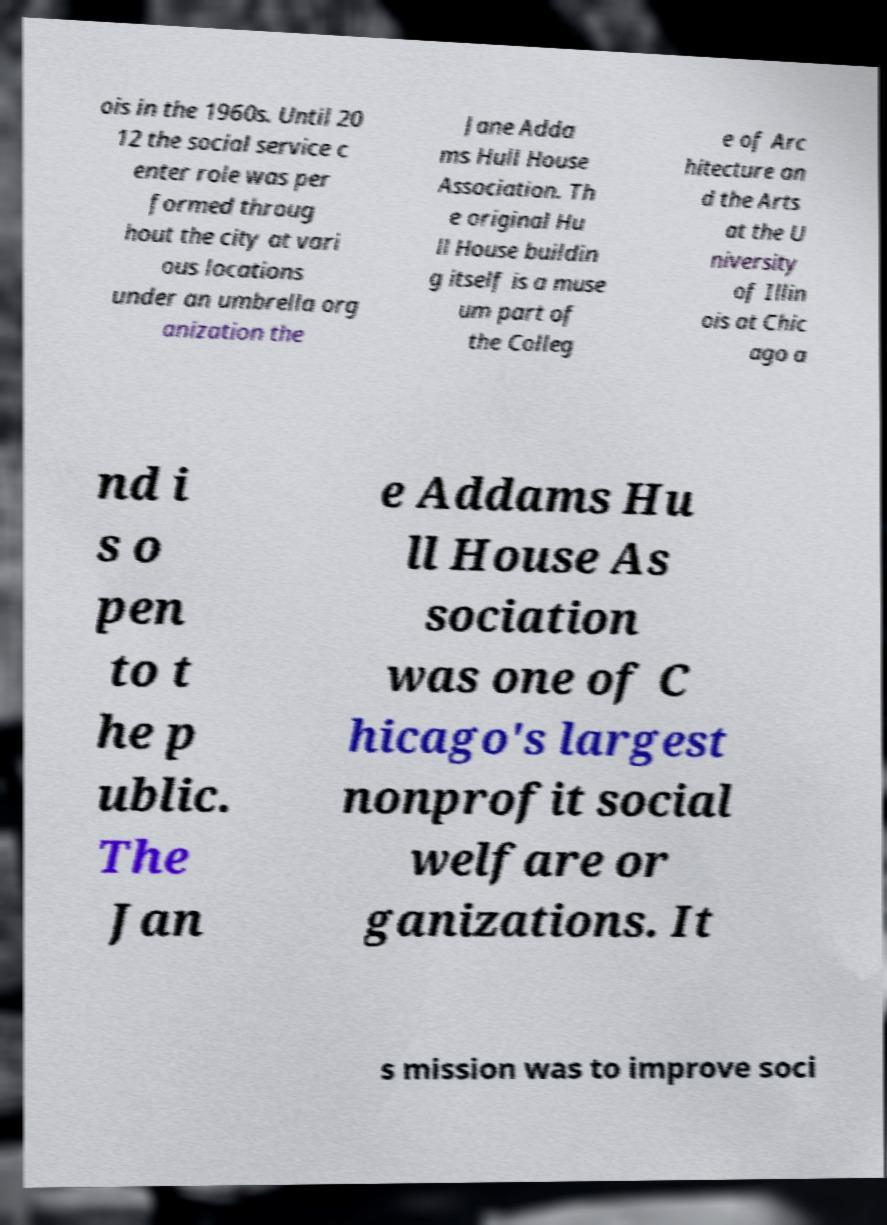I need the written content from this picture converted into text. Can you do that? ois in the 1960s. Until 20 12 the social service c enter role was per formed throug hout the city at vari ous locations under an umbrella org anization the Jane Adda ms Hull House Association. Th e original Hu ll House buildin g itself is a muse um part of the Colleg e of Arc hitecture an d the Arts at the U niversity of Illin ois at Chic ago a nd i s o pen to t he p ublic. The Jan e Addams Hu ll House As sociation was one of C hicago's largest nonprofit social welfare or ganizations. It s mission was to improve soci 